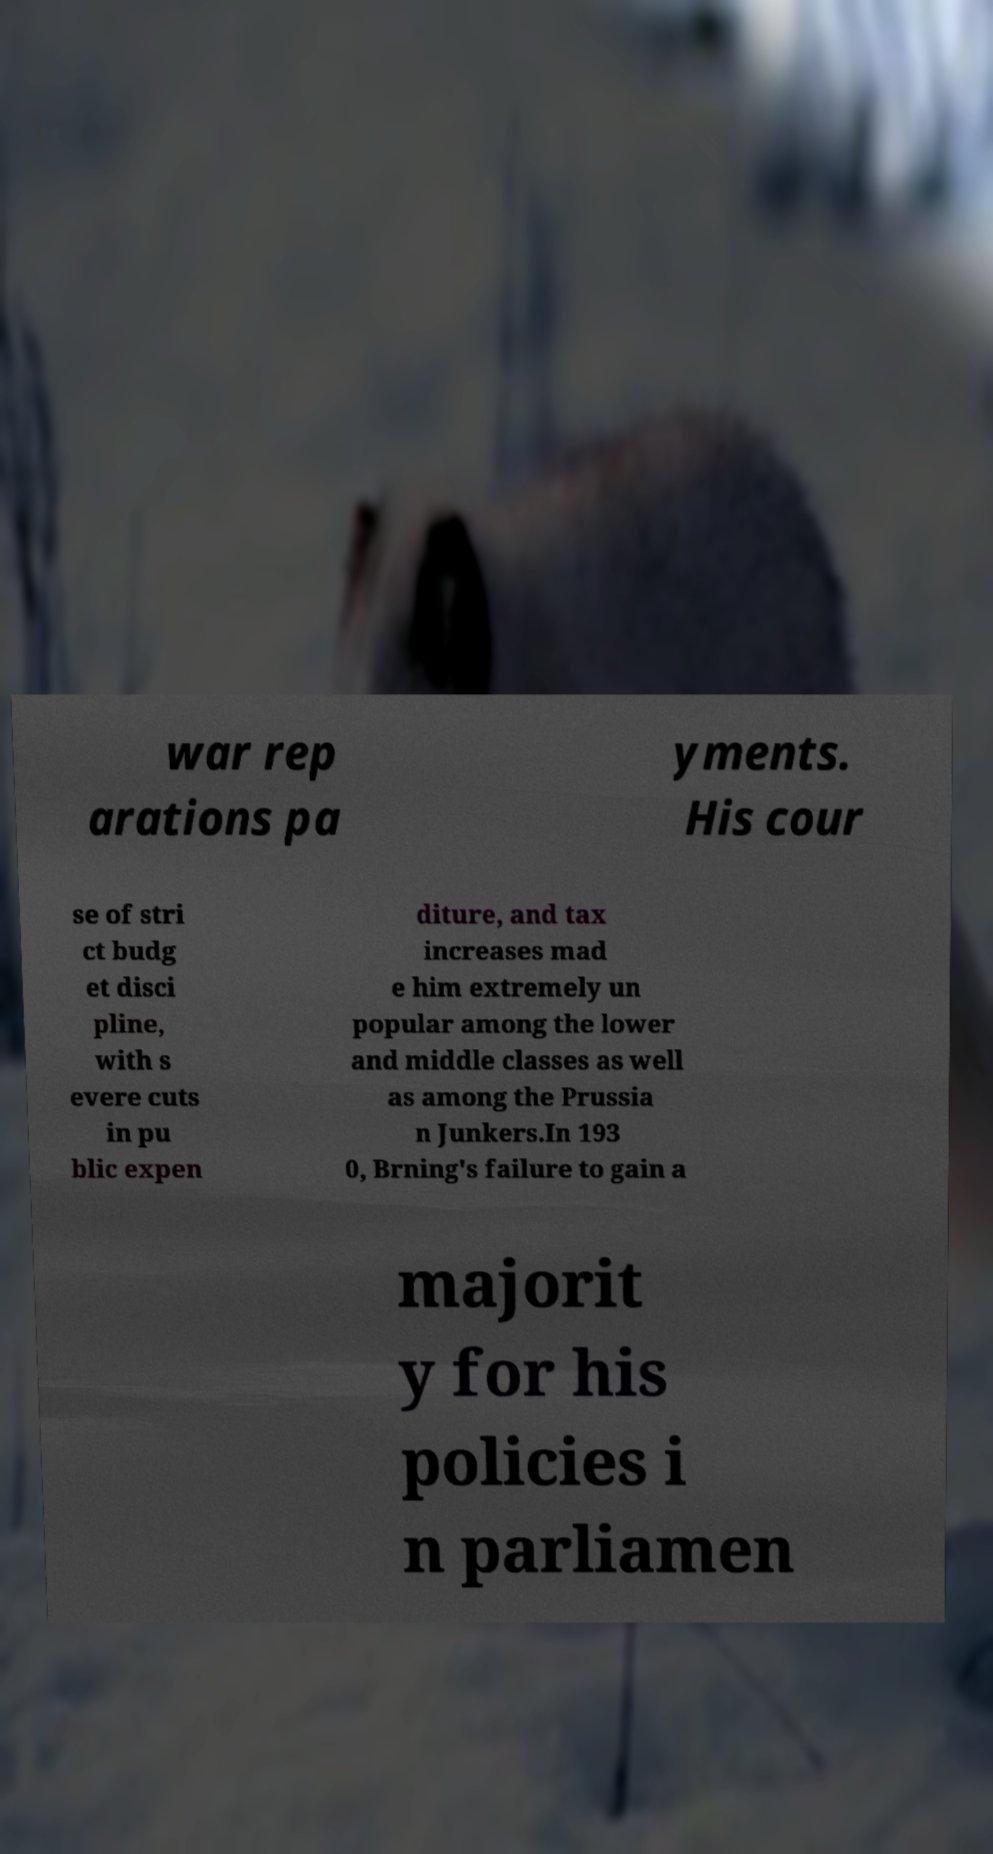Could you extract and type out the text from this image? war rep arations pa yments. His cour se of stri ct budg et disci pline, with s evere cuts in pu blic expen diture, and tax increases mad e him extremely un popular among the lower and middle classes as well as among the Prussia n Junkers.In 193 0, Brning's failure to gain a majorit y for his policies i n parliamen 